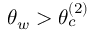<formula> <loc_0><loc_0><loc_500><loc_500>\theta _ { w } > \theta _ { c } ^ { ( 2 ) }</formula> 